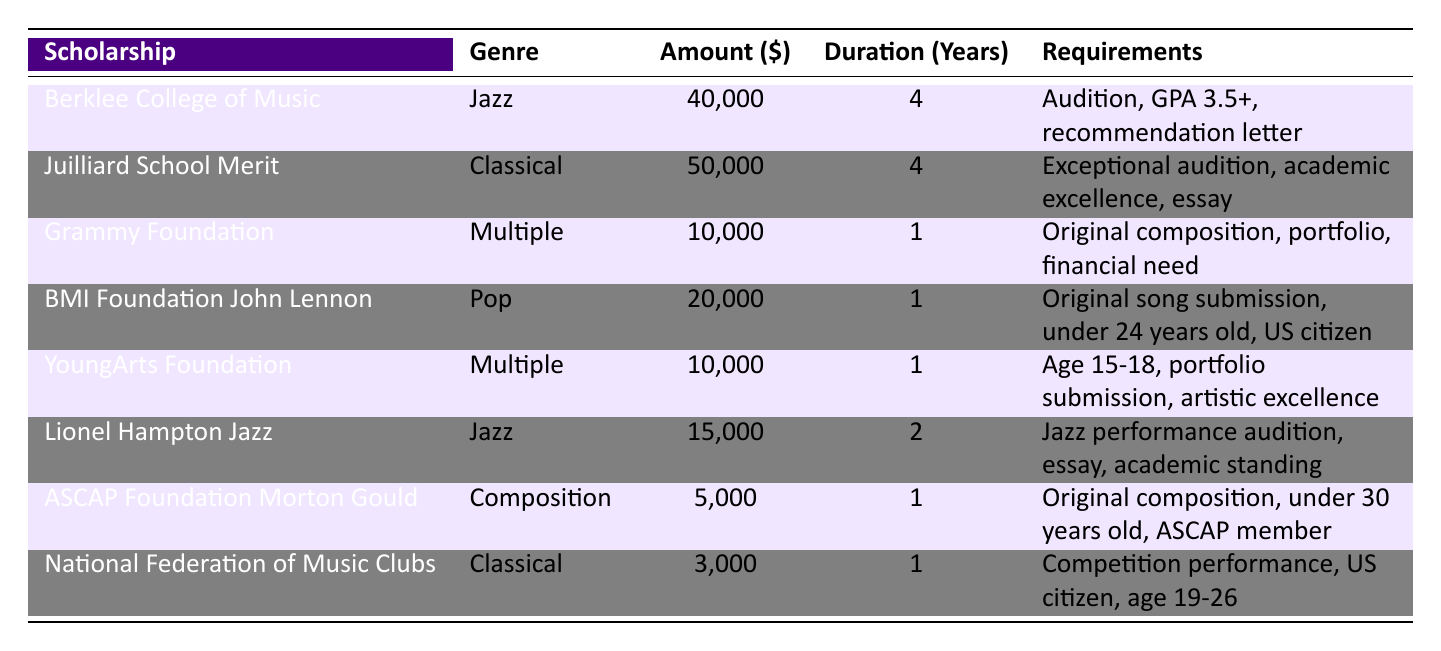What is the maximum scholarship amount available? The maximum amount listed in the table is found by scanning each scholarship's amount. The highest value is $50,000 from the Juilliard School Merit Scholarship.
Answer: 50,000 How long is the duration of the Berklee College of Music Scholarship? The duration of the Berklee College of Music Scholarship can be directly found in the table under the duration column, which shows it lasts for 4 years.
Answer: 4 years Is a recommendation letter required for the Grammy Foundation Scholarship? The requirements section for the Grammy Foundation Scholarship indicates that a recommendation letter is not mentioned, so the answer is no.
Answer: No Which genre has the most scholarships listed? To determine the genre with the most scholarships, count the number of entries for each genre: Jazz (2), Classical (2), Multiple (2), Pop (1), and Composition (1). Jazz, Classical, and Multiple each have 2 scholarships, tying for the most.
Answer: Jazz, Classical, Multiple What is the total amount of scholarships available for the Classical genre? To find the total amount for the Classical genre, sum the amounts for the Scholarships in this genre: Juilliard School Merit ($50,000) and National Federation of Music Clubs ($3,000), which totals $53,000.
Answer: 53,000 What percentage of scholarships requires an audition? The scholarships requiring an audition are Berklee College of Music, Juilliard School (though indirectly as part of "Exceptional audition"), Lionels Hampton Jazz scholarship, and National Federation of Music Clubs. That's a total of 4 out of 8 scholarships, which equals 50%.
Answer: 50% Do any scholarships have a duration of more than 1 year? Looking at the duration column, both the Berklee College of Music and Juilliard scholarships last for 4 years, Lionels Hampton Jazz lasts for 2 years. Hence, yes, there are scholarships with a duration of more than 1.
Answer: Yes Which scholarship requires an original composition? The scholarships that mention the requirement for an original composition are the Grammy Foundation Scholarship and ASCAP Foundation Morton Gould Young Composer Awards; thus, both meet this criterion.
Answer: Grammy Foundation Scholarship, ASCAP Foundation Morton Gould Young Composer Awards What is the average amount of the scholarships that last for 1 year? To find the average, identify the scholarships lasting 1 year: Grammy Foundation ($10,000), BMI Foundation ($20,000), YoungArts Foundation ($10,000), and ASCAP Foundation ($5,000). Calculate (10,000 + 20,000 + 10,000 + 5,000) = 45,000. Divide this by 4 (the number of scholarships) to get 11,250.
Answer: 11,250 Which scholarship has the lowest monetary value? Scanning through the amount column in the table, the one with the lowest value is the National Federation of Music Clubs Scholarship, which amounts to $3,000.
Answer: 3,000 